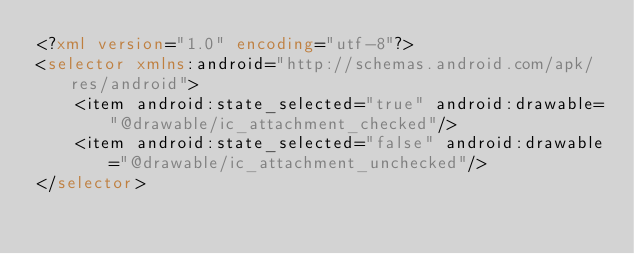<code> <loc_0><loc_0><loc_500><loc_500><_XML_><?xml version="1.0" encoding="utf-8"?>
<selector xmlns:android="http://schemas.android.com/apk/res/android">
    <item android:state_selected="true" android:drawable="@drawable/ic_attachment_checked"/>
    <item android:state_selected="false" android:drawable="@drawable/ic_attachment_unchecked"/>
</selector></code> 